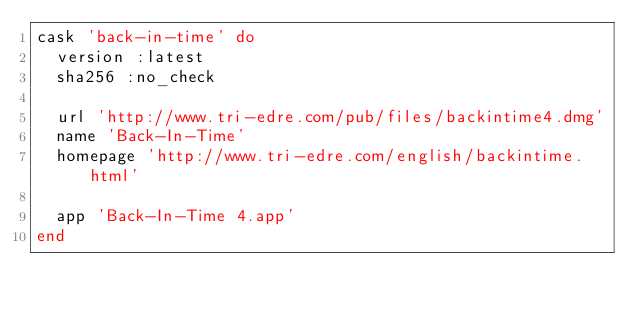Convert code to text. <code><loc_0><loc_0><loc_500><loc_500><_Ruby_>cask 'back-in-time' do
  version :latest
  sha256 :no_check

  url 'http://www.tri-edre.com/pub/files/backintime4.dmg'
  name 'Back-In-Time'
  homepage 'http://www.tri-edre.com/english/backintime.html'

  app 'Back-In-Time 4.app'
end
</code> 